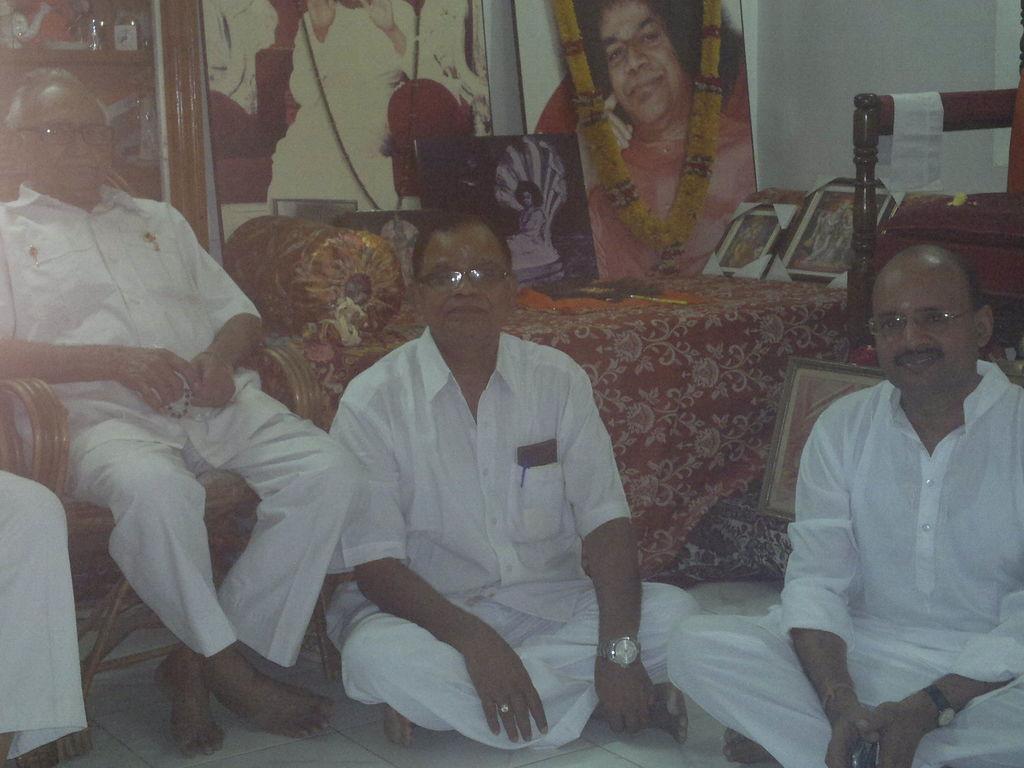Can you describe this image briefly? The picture is taken in a room. In the foreground of the picture there are men couches and frames. The wall is painted white. 